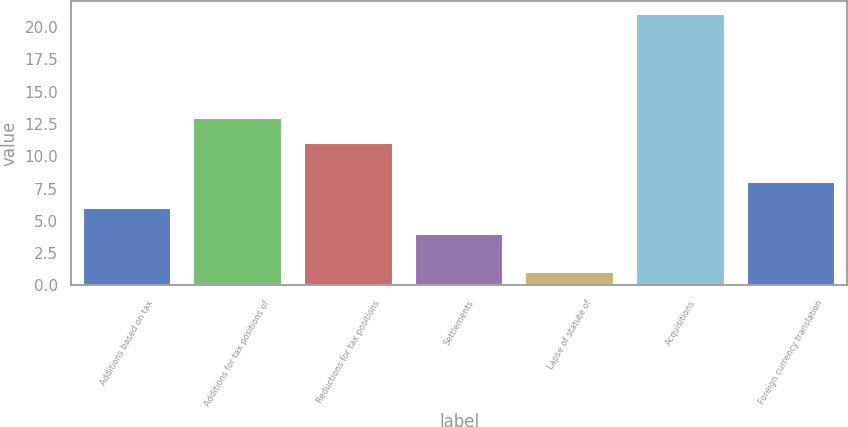Convert chart. <chart><loc_0><loc_0><loc_500><loc_500><bar_chart><fcel>Additions based on tax<fcel>Additions for tax positions of<fcel>Reductions for tax positions<fcel>Settlements<fcel>Lapse of statute of<fcel>Acquisitions<fcel>Foreign currency translation<nl><fcel>6<fcel>13<fcel>11<fcel>4<fcel>1<fcel>21<fcel>8<nl></chart> 